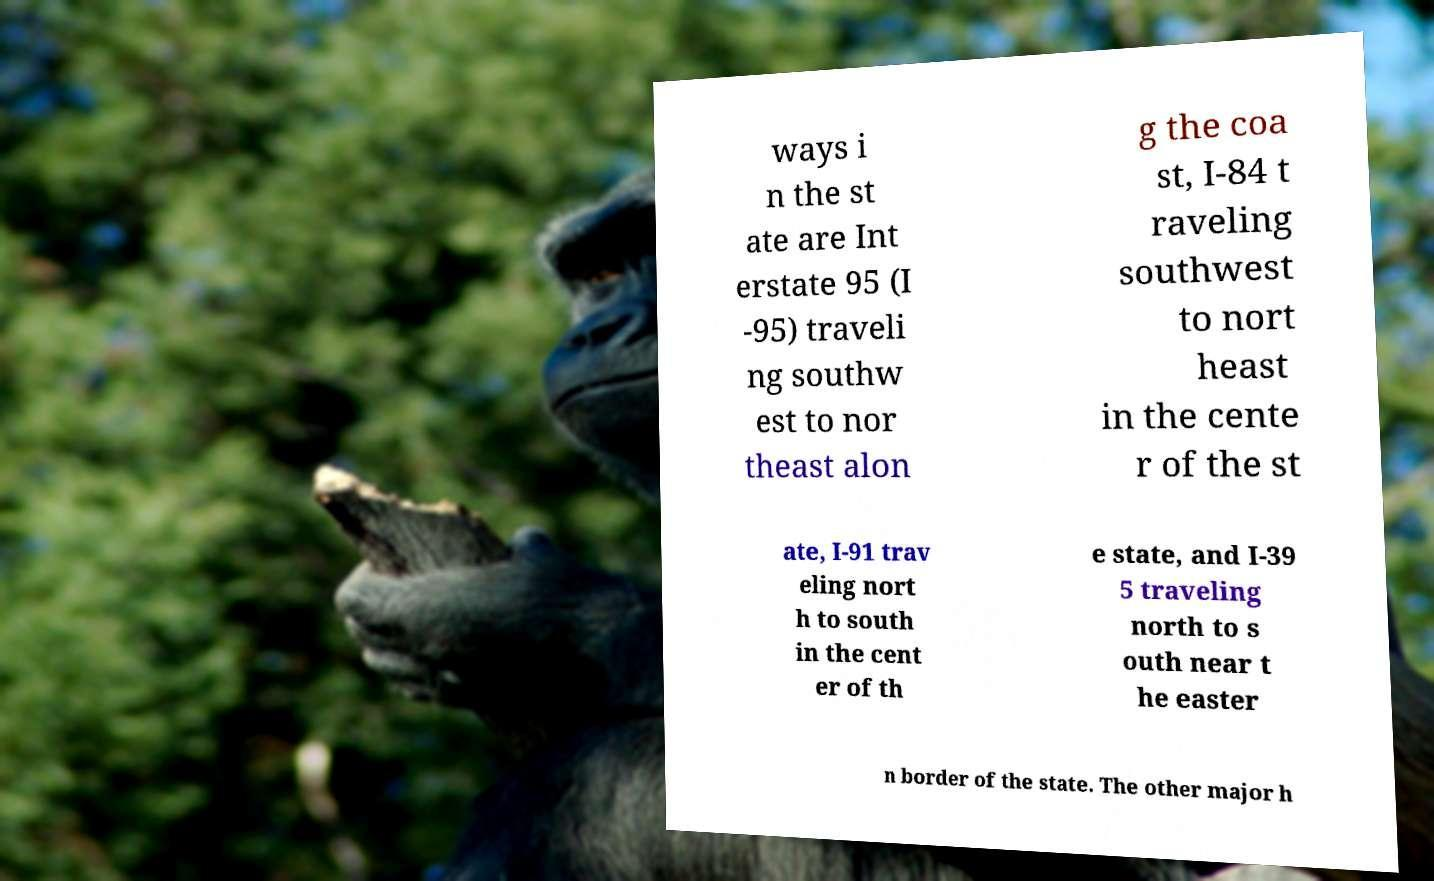Could you extract and type out the text from this image? ways i n the st ate are Int erstate 95 (I -95) traveli ng southw est to nor theast alon g the coa st, I-84 t raveling southwest to nort heast in the cente r of the st ate, I-91 trav eling nort h to south in the cent er of th e state, and I-39 5 traveling north to s outh near t he easter n border of the state. The other major h 